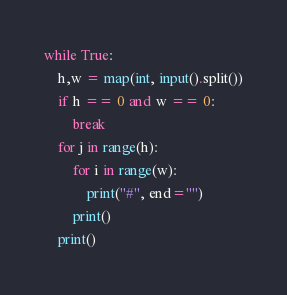Convert code to text. <code><loc_0><loc_0><loc_500><loc_500><_Python_>while True:
    h,w = map(int, input().split())
    if h == 0 and w == 0:
        break
    for j in range(h):
        for i in range(w):
            print("#", end="")
        print()
    print()
</code> 